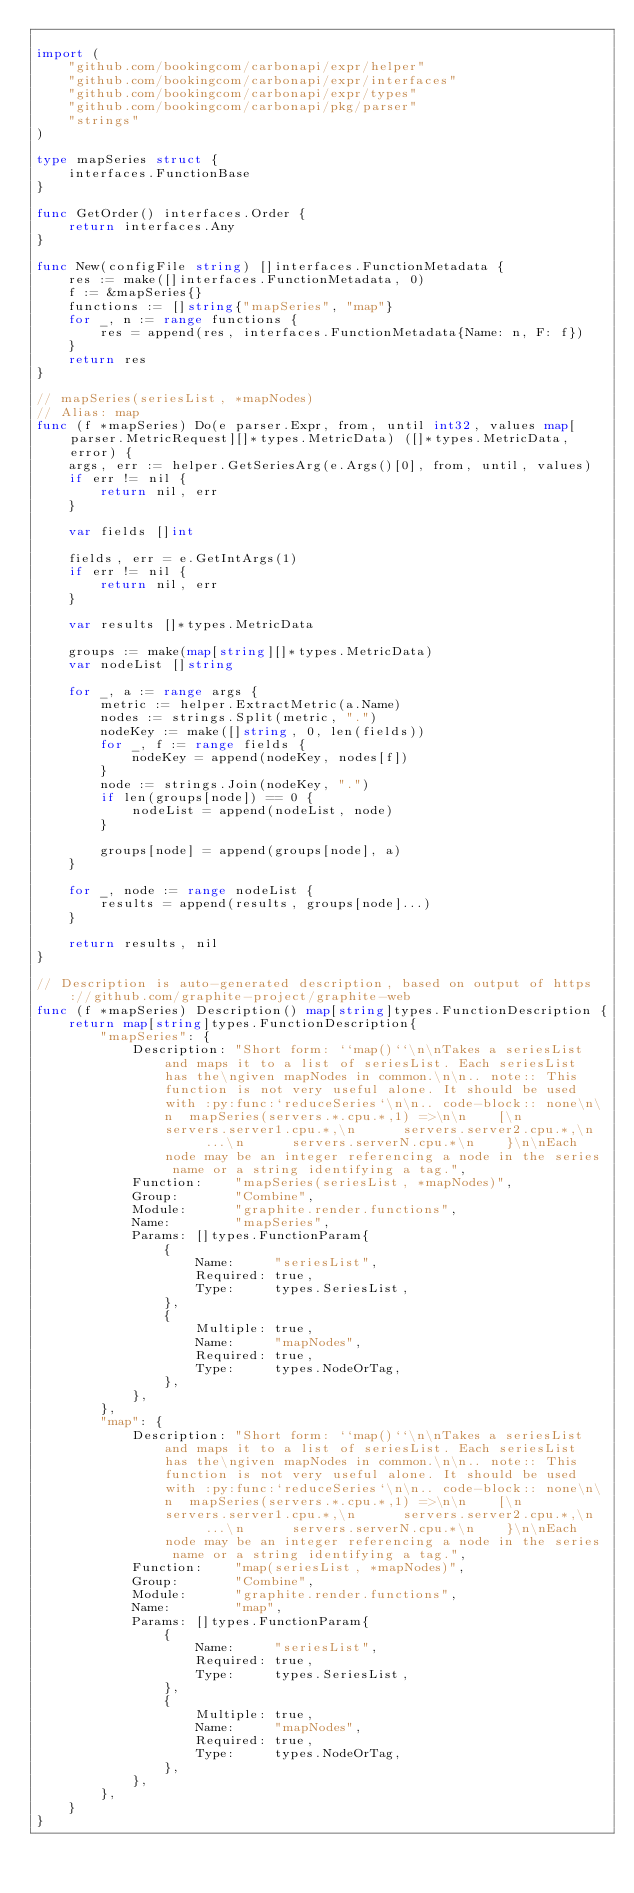<code> <loc_0><loc_0><loc_500><loc_500><_Go_>
import (
	"github.com/bookingcom/carbonapi/expr/helper"
	"github.com/bookingcom/carbonapi/expr/interfaces"
	"github.com/bookingcom/carbonapi/expr/types"
	"github.com/bookingcom/carbonapi/pkg/parser"
	"strings"
)

type mapSeries struct {
	interfaces.FunctionBase
}

func GetOrder() interfaces.Order {
	return interfaces.Any
}

func New(configFile string) []interfaces.FunctionMetadata {
	res := make([]interfaces.FunctionMetadata, 0)
	f := &mapSeries{}
	functions := []string{"mapSeries", "map"}
	for _, n := range functions {
		res = append(res, interfaces.FunctionMetadata{Name: n, F: f})
	}
	return res
}

// mapSeries(seriesList, *mapNodes)
// Alias: map
func (f *mapSeries) Do(e parser.Expr, from, until int32, values map[parser.MetricRequest][]*types.MetricData) ([]*types.MetricData, error) {
	args, err := helper.GetSeriesArg(e.Args()[0], from, until, values)
	if err != nil {
		return nil, err
	}

	var fields []int

	fields, err = e.GetIntArgs(1)
	if err != nil {
		return nil, err
	}

	var results []*types.MetricData

	groups := make(map[string][]*types.MetricData)
	var nodeList []string

	for _, a := range args {
		metric := helper.ExtractMetric(a.Name)
		nodes := strings.Split(metric, ".")
		nodeKey := make([]string, 0, len(fields))
		for _, f := range fields {
			nodeKey = append(nodeKey, nodes[f])
		}
		node := strings.Join(nodeKey, ".")
		if len(groups[node]) == 0 {
			nodeList = append(nodeList, node)
		}

		groups[node] = append(groups[node], a)
	}

	for _, node := range nodeList {
		results = append(results, groups[node]...)
	}

	return results, nil
}

// Description is auto-generated description, based on output of https://github.com/graphite-project/graphite-web
func (f *mapSeries) Description() map[string]types.FunctionDescription {
	return map[string]types.FunctionDescription{
		"mapSeries": {
			Description: "Short form: ``map()``\n\nTakes a seriesList and maps it to a list of seriesList. Each seriesList has the\ngiven mapNodes in common.\n\n.. note:: This function is not very useful alone. It should be used with :py:func:`reduceSeries`\n\n.. code-block:: none\n\n  mapSeries(servers.*.cpu.*,1) =>\n\n    [\n      servers.server1.cpu.*,\n      servers.server2.cpu.*,\n      ...\n      servers.serverN.cpu.*\n    }\n\nEach node may be an integer referencing a node in the series name or a string identifying a tag.",
			Function:    "mapSeries(seriesList, *mapNodes)",
			Group:       "Combine",
			Module:      "graphite.render.functions",
			Name:        "mapSeries",
			Params: []types.FunctionParam{
				{
					Name:     "seriesList",
					Required: true,
					Type:     types.SeriesList,
				},
				{
					Multiple: true,
					Name:     "mapNodes",
					Required: true,
					Type:     types.NodeOrTag,
				},
			},
		},
		"map": {
			Description: "Short form: ``map()``\n\nTakes a seriesList and maps it to a list of seriesList. Each seriesList has the\ngiven mapNodes in common.\n\n.. note:: This function is not very useful alone. It should be used with :py:func:`reduceSeries`\n\n.. code-block:: none\n\n  mapSeries(servers.*.cpu.*,1) =>\n\n    [\n      servers.server1.cpu.*,\n      servers.server2.cpu.*,\n      ...\n      servers.serverN.cpu.*\n    }\n\nEach node may be an integer referencing a node in the series name or a string identifying a tag.",
			Function:    "map(seriesList, *mapNodes)",
			Group:       "Combine",
			Module:      "graphite.render.functions",
			Name:        "map",
			Params: []types.FunctionParam{
				{
					Name:     "seriesList",
					Required: true,
					Type:     types.SeriesList,
				},
				{
					Multiple: true,
					Name:     "mapNodes",
					Required: true,
					Type:     types.NodeOrTag,
				},
			},
		},
	}
}
</code> 